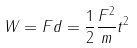Convert formula to latex. <formula><loc_0><loc_0><loc_500><loc_500>W = F d = \frac { 1 } { 2 } \frac { F ^ { 2 } } { m } t ^ { 2 }</formula> 